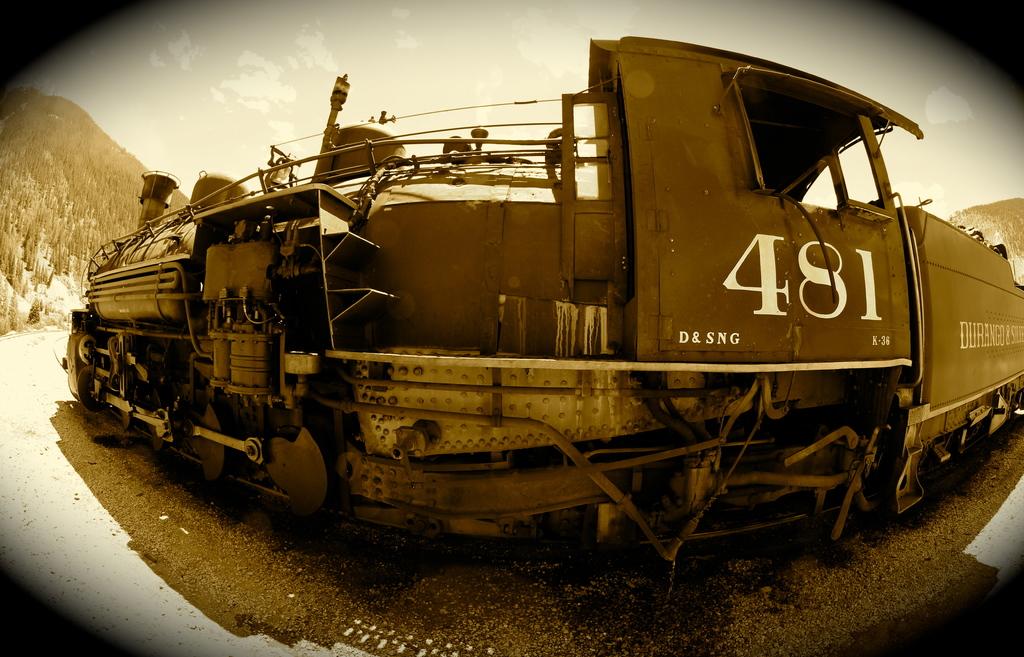What is the train's number?
Keep it short and to the point. 481. 